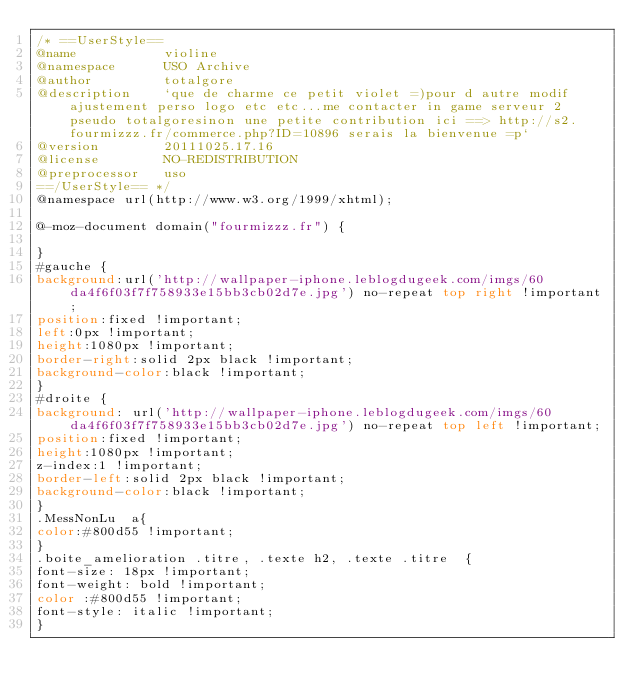<code> <loc_0><loc_0><loc_500><loc_500><_CSS_>/* ==UserStyle==
@name           violine
@namespace      USO Archive
@author         totalgore
@description    `que de charme ce petit violet =)pour d autre modif ajustement perso logo etc etc...me contacter in game serveur 2 pseudo totalgoresinon une petite contribution ici ==> http://s2.fourmizzz.fr/commerce.php?ID=10896 serais la bienvenue =p`
@version        20111025.17.16
@license        NO-REDISTRIBUTION
@preprocessor   uso
==/UserStyle== */
@namespace url(http://www.w3.org/1999/xhtml);

@-moz-document domain("fourmizzz.fr") {

}
#gauche {
background:url('http://wallpaper-iphone.leblogdugeek.com/imgs/60da4f6f03f7f758933e15bb3cb02d7e.jpg') no-repeat top right !important;
position:fixed !important;
left:0px !important; 
height:1080px !important;
border-right:solid 2px black !important;
background-color:black !important;
}
#droite {
background: url('http://wallpaper-iphone.leblogdugeek.com/imgs/60da4f6f03f7f758933e15bb3cb02d7e.jpg') no-repeat top left !important;
position:fixed !important;
height:1080px !important;
z-index:1 !important;
border-left:solid 2px black !important;
background-color:black !important;
}
.MessNonLu  a{
color:#800d55 !important;
}
.boite_amelioration .titre, .texte h2, .texte .titre  {
font-size: 18px !important;
font-weight: bold !important;
color :#800d55 !important;
font-style: italic !important;
}</code> 